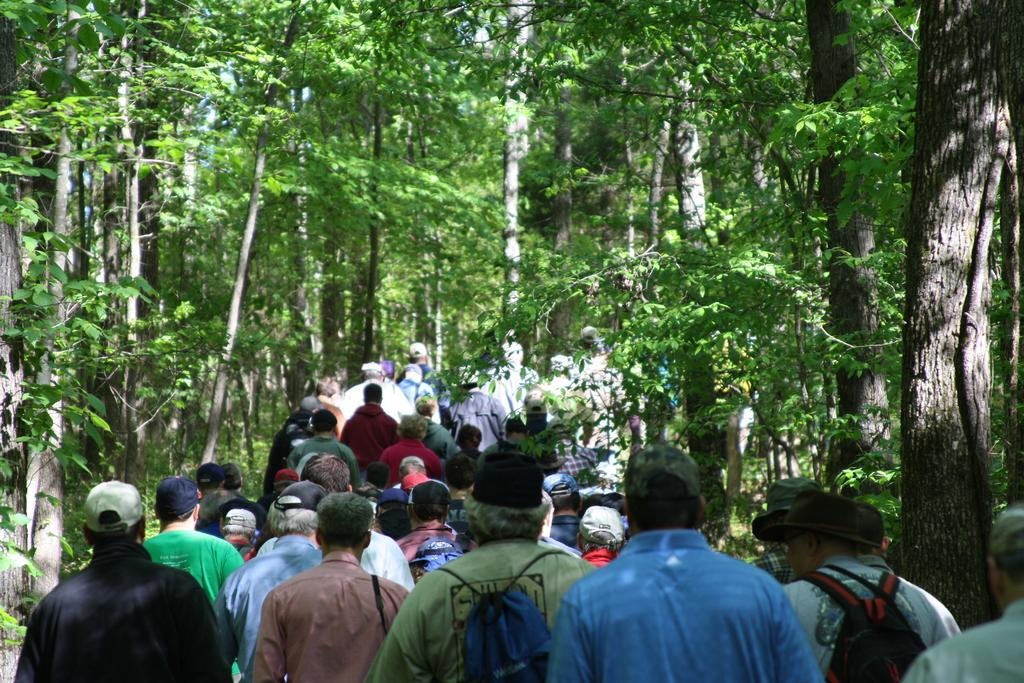Where was the image most likely taken? The image was taken in a park or a forest. What are the people in the image doing? The people in the center of the image are walking. What can be seen in the background of the image? There are trees in the background of the image. What is the weather like in the image? It is sunny in the image. What news headline is being discussed by the people walking in the image? There is no indication in the image that the people are discussing any news headlines. Can you see a kite flying in the image? There is no kite visible in the image. 